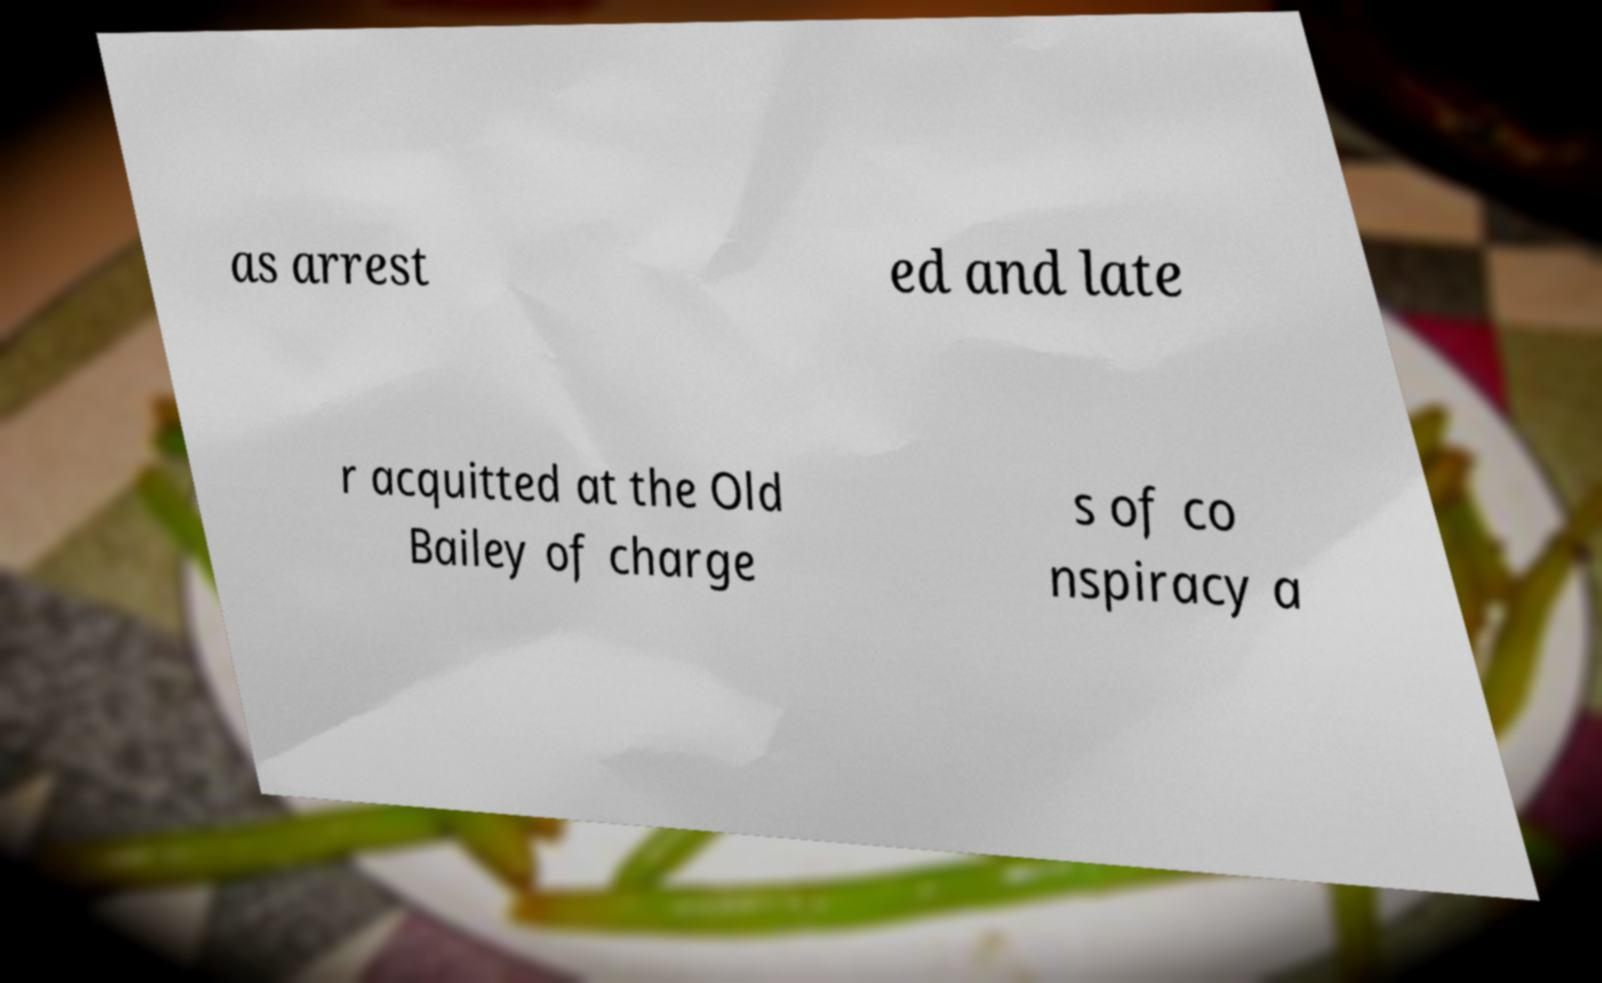For documentation purposes, I need the text within this image transcribed. Could you provide that? as arrest ed and late r acquitted at the Old Bailey of charge s of co nspiracy a 